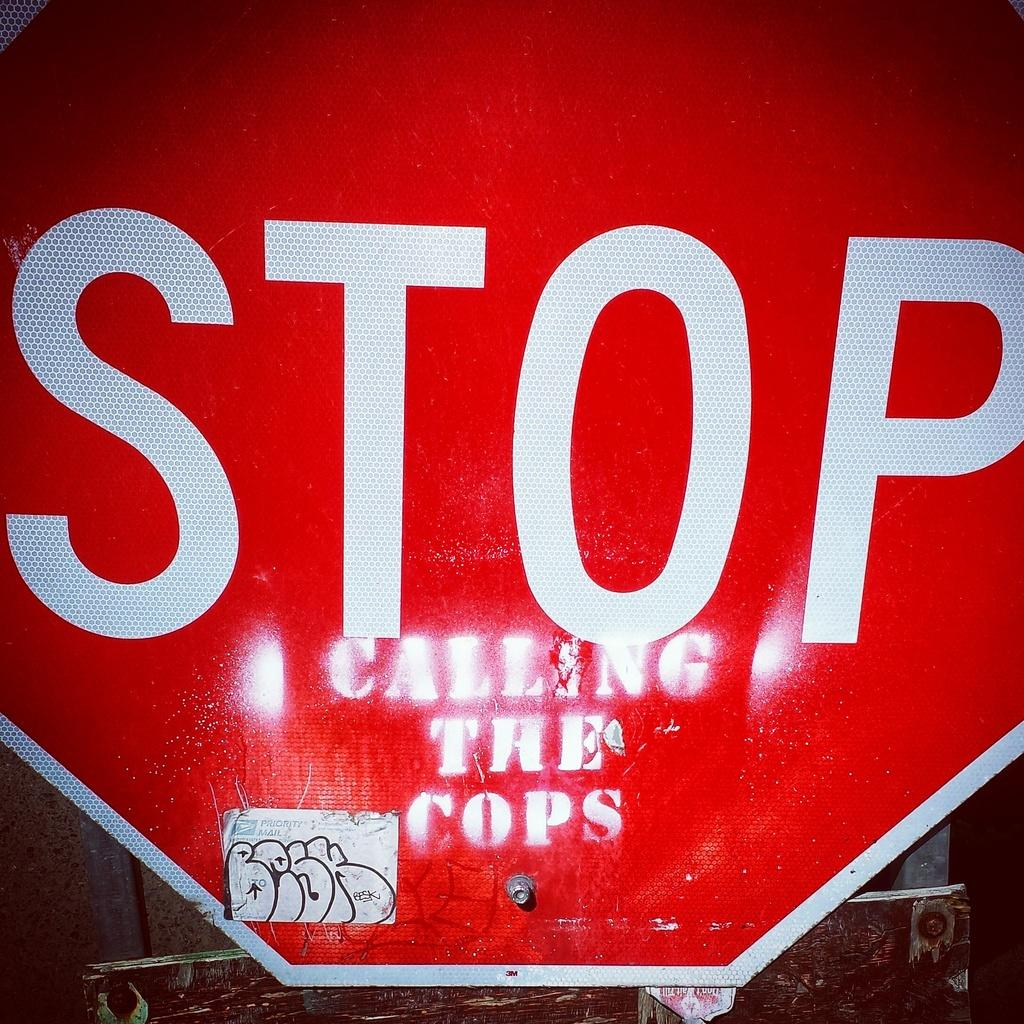<image>
Create a compact narrative representing the image presented. A stop sign with a grafitti message painted on it that says calling the cops. 